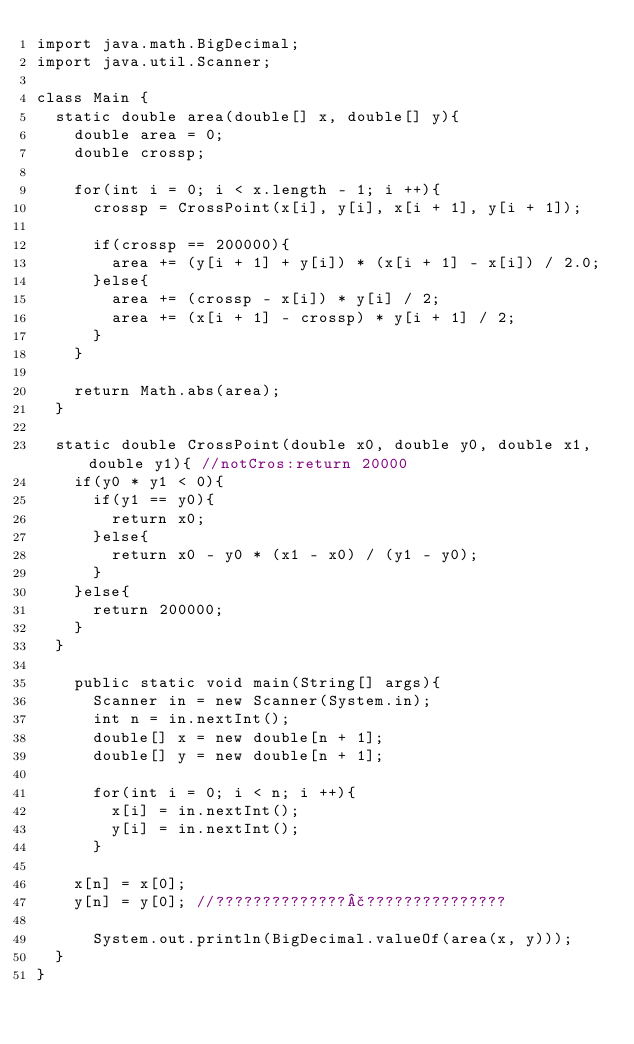Convert code to text. <code><loc_0><loc_0><loc_500><loc_500><_Java_>import java.math.BigDecimal;
import java.util.Scanner;

class Main {
	static double area(double[] x, double[] y){
		double area = 0;
		double crossp;
		
		for(int i = 0; i < x.length - 1; i ++){
			crossp = CrossPoint(x[i], y[i], x[i + 1], y[i + 1]);
			
			if(crossp == 200000){
				area += (y[i + 1] + y[i]) * (x[i + 1] - x[i]) / 2.0;
			}else{
				area += (crossp - x[i]) * y[i] / 2;
				area += (x[i + 1] - crossp) * y[i + 1] / 2;
			}
		}
		
		return Math.abs(area);
	}
	
	static double CrossPoint(double x0, double y0, double x1, double y1){ //notCros:return 20000
		if(y0 * y1 < 0){
			if(y1 == y0){
				return x0;
			}else{
				return x0 - y0 * (x1 - x0) / (y1 - y0);
			}
		}else{
			return 200000;
		}
	}
	
    public static void main(String[] args){
    	Scanner in = new Scanner(System.in);
    	int n = in.nextInt();
    	double[] x = new double[n + 1];
    	double[] y = new double[n + 1];
    	
    	for(int i = 0; i < n; i ++){
    		x[i] = in.nextInt();
    		y[i] = in.nextInt();
    	}

		x[n] = x[0];
		y[n] = y[0]; //??????????????£???????????????
    	
    	System.out.println(BigDecimal.valueOf(area(x, y)));
	}
}</code> 